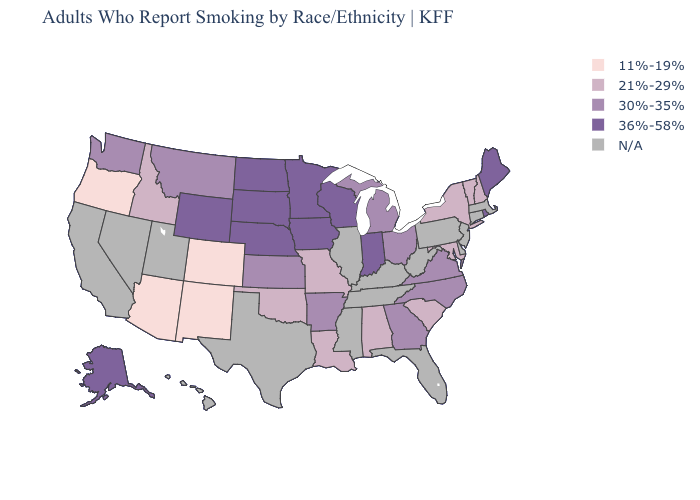Among the states that border Missouri , which have the lowest value?
Short answer required. Oklahoma. What is the value of Kentucky?
Give a very brief answer. N/A. Among the states that border Montana , does Idaho have the lowest value?
Be succinct. Yes. What is the value of Rhode Island?
Keep it brief. 36%-58%. Name the states that have a value in the range 11%-19%?
Give a very brief answer. Arizona, Colorado, New Mexico, Oregon. Among the states that border Virginia , does North Carolina have the lowest value?
Give a very brief answer. No. Is the legend a continuous bar?
Answer briefly. No. Does the map have missing data?
Keep it brief. Yes. Does Michigan have the lowest value in the MidWest?
Quick response, please. No. What is the value of West Virginia?
Short answer required. N/A. Name the states that have a value in the range 11%-19%?
Concise answer only. Arizona, Colorado, New Mexico, Oregon. Name the states that have a value in the range N/A?
Give a very brief answer. California, Connecticut, Delaware, Florida, Hawaii, Illinois, Kentucky, Massachusetts, Mississippi, Nevada, New Jersey, Pennsylvania, Tennessee, Texas, Utah, West Virginia. What is the lowest value in states that border Texas?
Quick response, please. 11%-19%. 